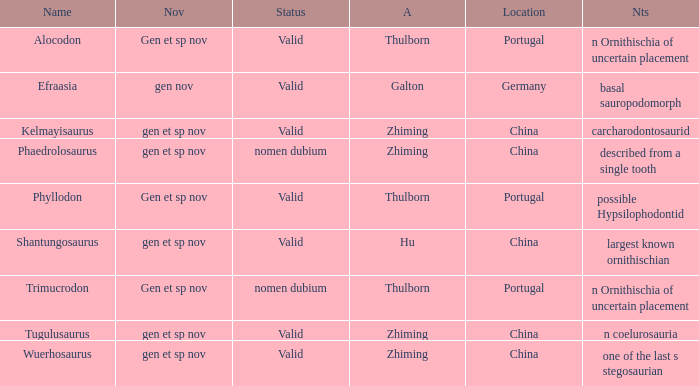What is the Novelty of the dinosaur that was named by the Author, Zhiming, and whose Notes are, "carcharodontosaurid"? Gen et sp nov. 